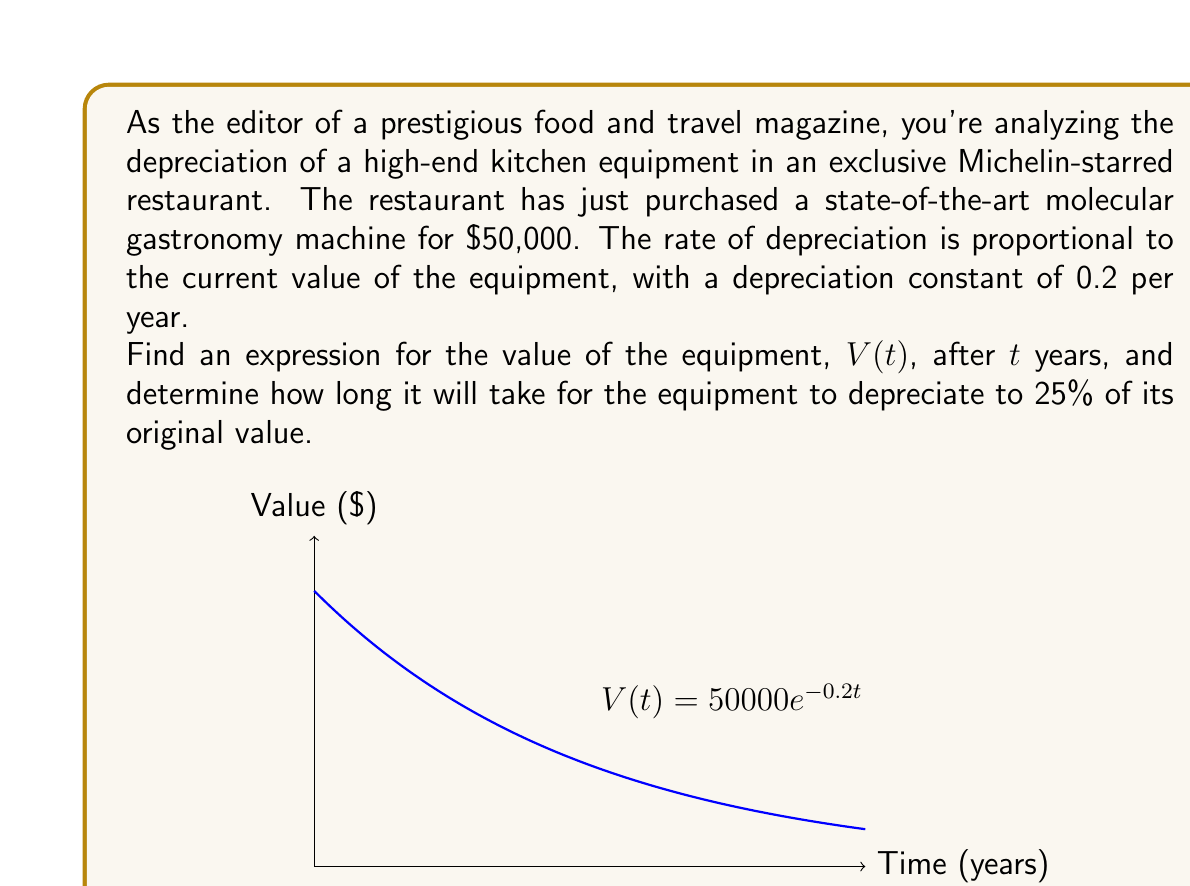Solve this math problem. Let's approach this step-by-step:

1) The rate of change of the equipment's value is proportional to its current value. This can be expressed as a differential equation:

   $$\frac{dV}{dt} = -kV$$

   where $k$ is the depreciation constant (0.2 in this case).

2) This is a separable first-order differential equation. We can solve it as follows:

   $$\frac{dV}{V} = -k dt$$

3) Integrating both sides:

   $$\int \frac{dV}{V} = -k \int dt$$
   $$\ln|V| = -kt + C$$

4) Taking the exponential of both sides:

   $$V = e^{-kt + C} = e^C \cdot e^{-kt}$$

5) Let $A = e^C$. At $t=0$, $V = 50000$, so:

   $$50000 = A \cdot e^{-k \cdot 0} = A$$

6) Therefore, the general solution is:

   $$V(t) = 50000e^{-0.2t}$$

7) To find when the value is 25% of the original, we solve:

   $$50000e^{-0.2t} = 0.25 \cdot 50000$$
   $$e^{-0.2t} = 0.25$$
   $$-0.2t = \ln(0.25) = -1.3863$$
   $$t = \frac{1.3863}{0.2} = 6.9315$$
Answer: $V(t) = 50000e^{-0.2t}$; 6.9315 years 